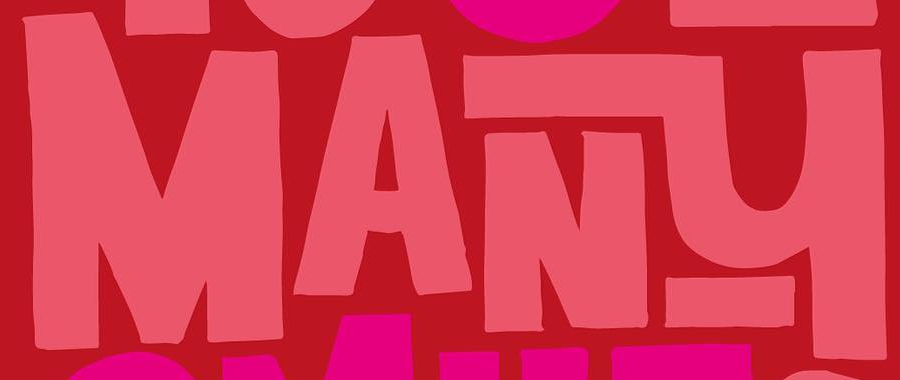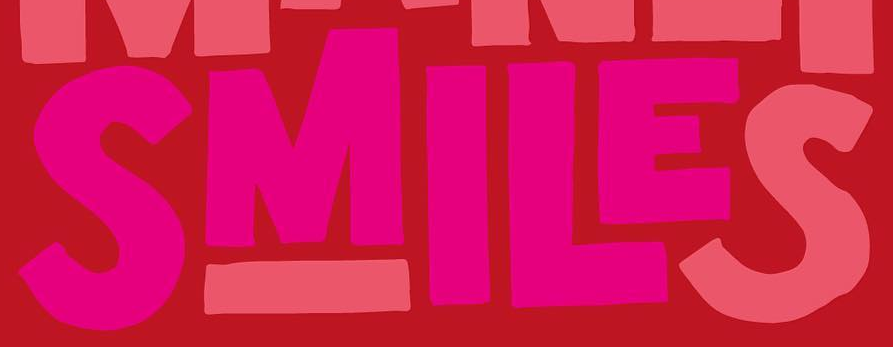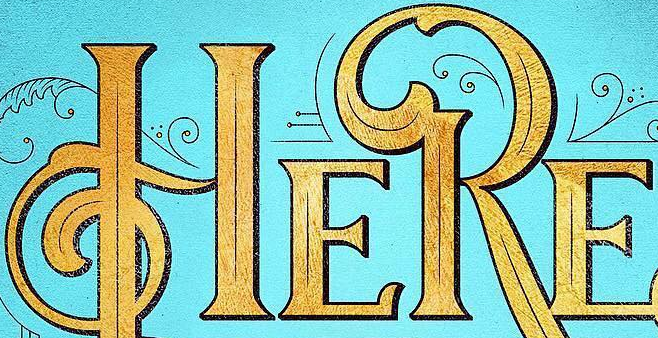Transcribe the words shown in these images in order, separated by a semicolon. MANY; SMILES; HERE 